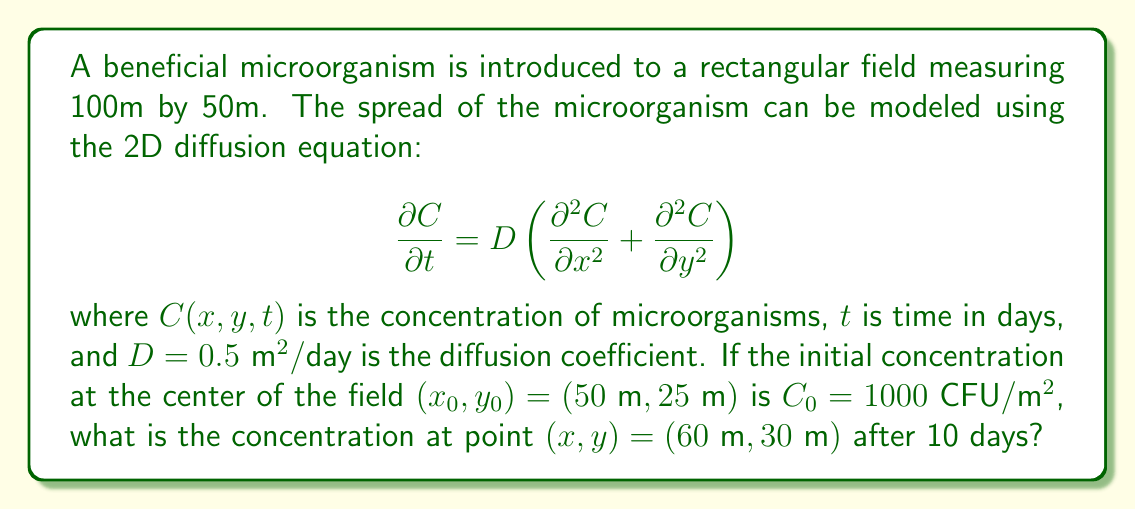Solve this math problem. To solve this problem, we can use the 2D diffusion equation solution for an instantaneous point source:

$$C(x,y,t) = \frac{C_0}{4\pi Dt} \exp\left(-\frac{(x-x_0)^2 + (y-y_0)^2}{4Dt}\right)$$

Let's follow these steps:

1) Identify the known values:
   $C_0 = 1000 \text{ CFU}/\text{m}^2$
   $D = 0.5 \text{ m}^2/\text{day}$
   $t = 10 \text{ days}$
   $(x_0, y_0) = (50\text{ m}, 25\text{ m})$
   $(x, y) = (60\text{ m}, 30\text{ m})$

2) Calculate the distance between the initial point and the point of interest:
   $$(x-x_0)^2 + (y-y_0)^2 = (60-50)^2 + (30-25)^2 = 10^2 + 5^2 = 125 \text{ m}^2$$

3) Substitute all values into the equation:

   $$C(60,30,10) = \frac{1000}{4\pi(0.5)(10)} \exp\left(-\frac{125}{4(0.5)(10)}\right)$$

4) Simplify:
   $$C(60,30,10) = \frac{1000}{20\pi} \exp\left(-\frac{125}{20}\right)$$

5) Calculate:
   $$C(60,30,10) \approx 15.92 \text{ CFU}/\text{m}^2$$

Therefore, the concentration at point (60m, 30m) after 10 days is approximately 15.92 CFU/m².
Answer: 15.92 CFU/m² 